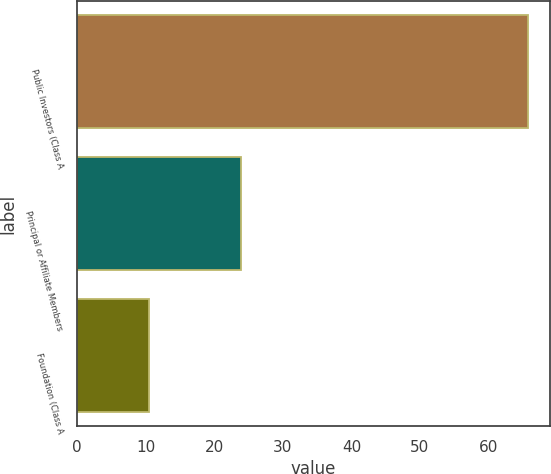Convert chart to OTSL. <chart><loc_0><loc_0><loc_500><loc_500><bar_chart><fcel>Public Investors (Class A<fcel>Principal or Affiliate Members<fcel>Foundation (Class A<nl><fcel>65.7<fcel>23.9<fcel>10.4<nl></chart> 